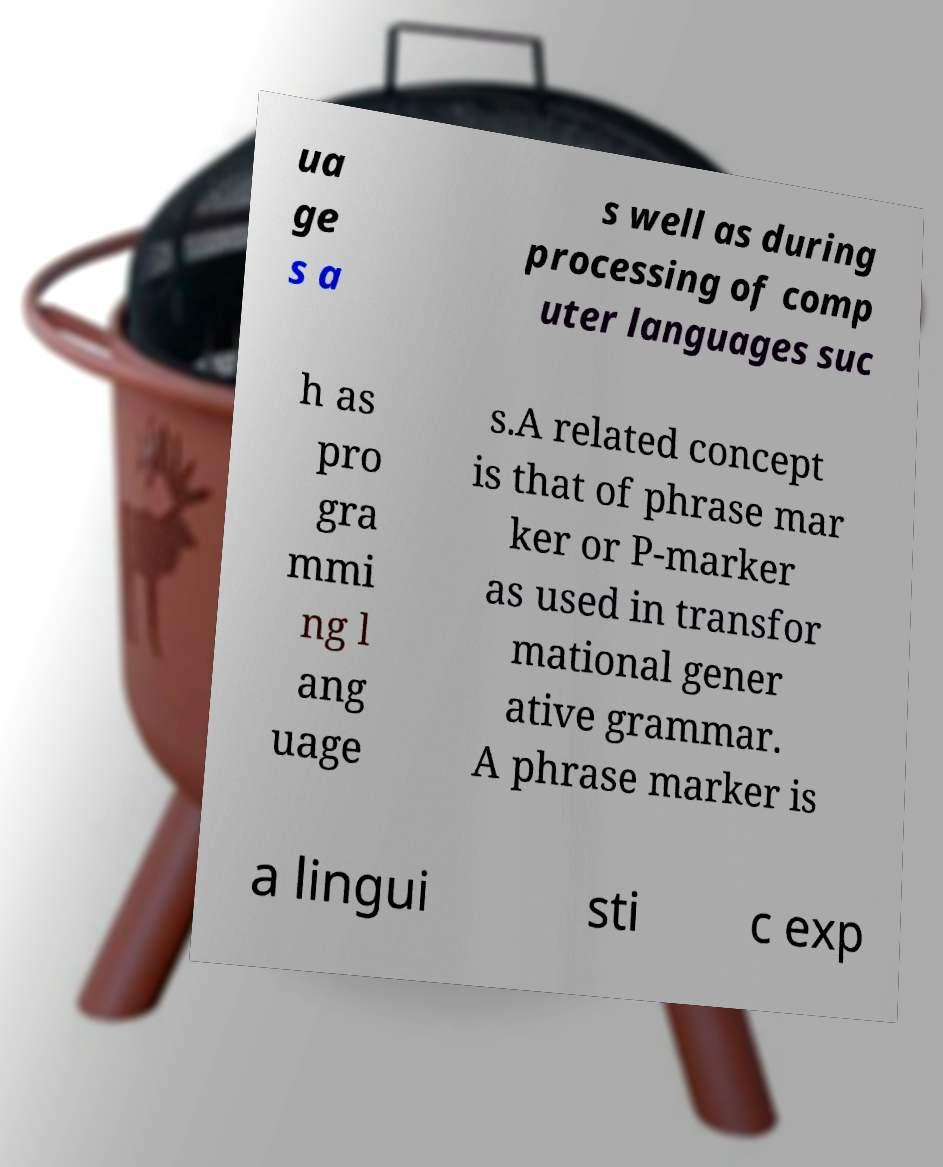What messages or text are displayed in this image? I need them in a readable, typed format. ua ge s a s well as during processing of comp uter languages suc h as pro gra mmi ng l ang uage s.A related concept is that of phrase mar ker or P-marker as used in transfor mational gener ative grammar. A phrase marker is a lingui sti c exp 